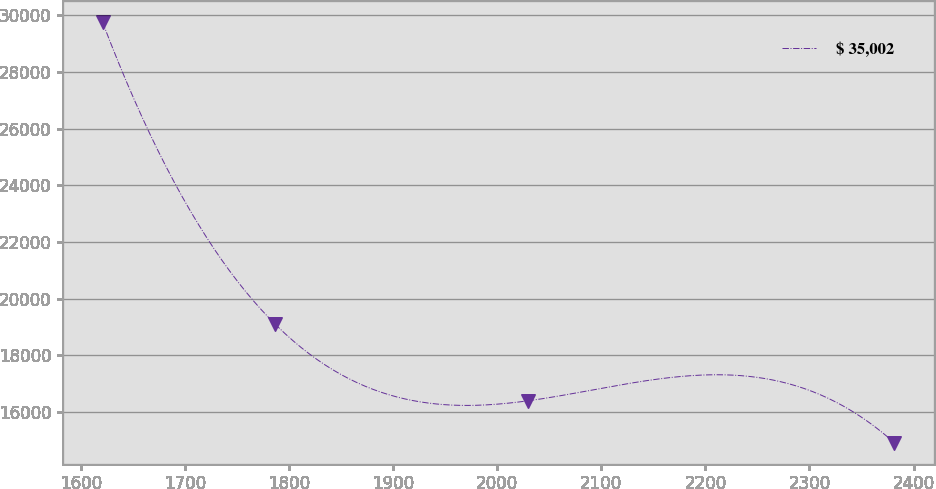Convert chart to OTSL. <chart><loc_0><loc_0><loc_500><loc_500><line_chart><ecel><fcel>$ 35,002<nl><fcel>1620.84<fcel>29742.9<nl><fcel>1786.66<fcel>19094.6<nl><fcel>2029.82<fcel>16395<nl><fcel>2381.57<fcel>14911.9<nl></chart> 